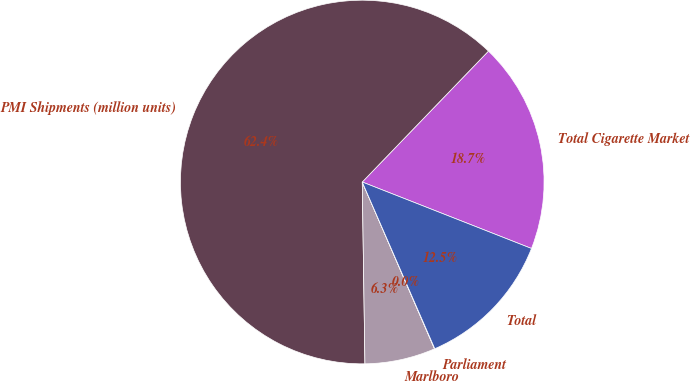Convert chart to OTSL. <chart><loc_0><loc_0><loc_500><loc_500><pie_chart><fcel>Total Cigarette Market<fcel>PMI Shipments (million units)<fcel>Marlboro<fcel>Parliament<fcel>Total<nl><fcel>18.75%<fcel>62.45%<fcel>6.27%<fcel>0.03%<fcel>12.51%<nl></chart> 